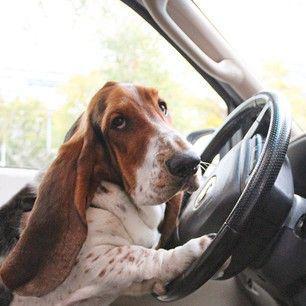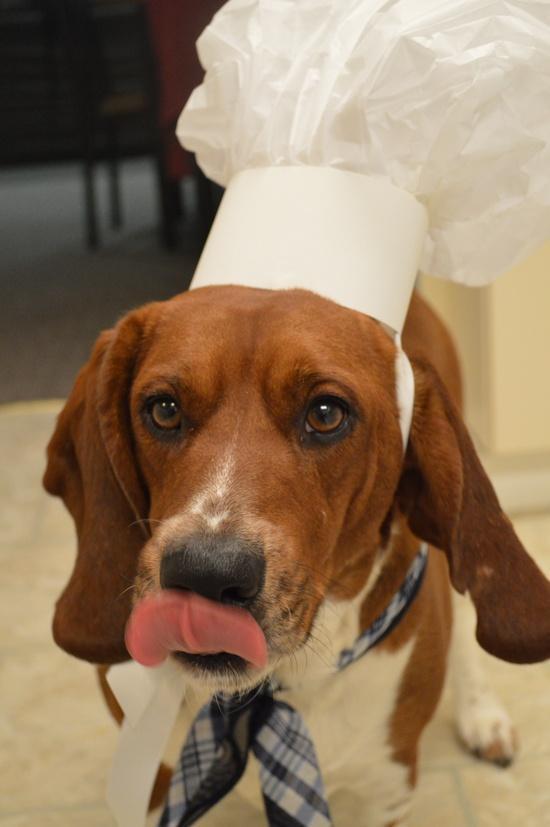The first image is the image on the left, the second image is the image on the right. For the images displayed, is the sentence "One image shows a forward-facing hound posed indoors wearing some type of outfit that includes a scarf." factually correct? Answer yes or no. Yes. The first image is the image on the left, the second image is the image on the right. Examine the images to the left and right. Is the description "One of the dogs is wearing an item of clothing." accurate? Answer yes or no. Yes. 